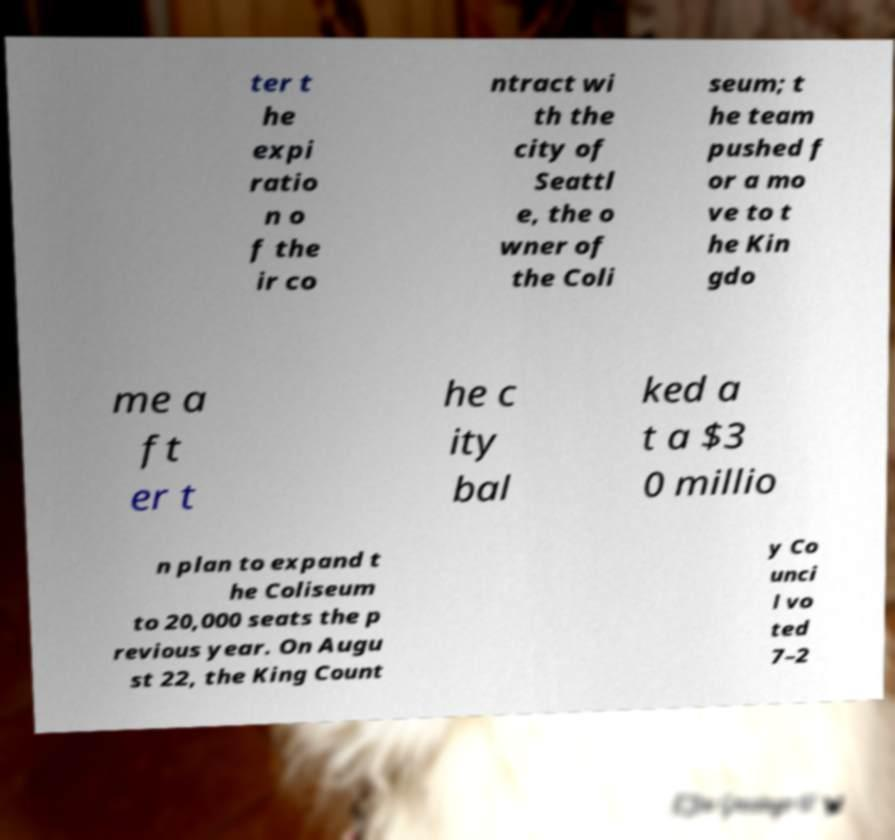I need the written content from this picture converted into text. Can you do that? ter t he expi ratio n o f the ir co ntract wi th the city of Seattl e, the o wner of the Coli seum; t he team pushed f or a mo ve to t he Kin gdo me a ft er t he c ity bal ked a t a $3 0 millio n plan to expand t he Coliseum to 20,000 seats the p revious year. On Augu st 22, the King Count y Co unci l vo ted 7–2 